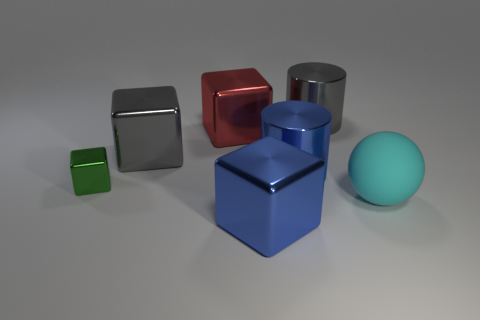Subtract 1 blocks. How many blocks are left? 3 Add 2 large yellow rubber objects. How many objects exist? 9 Subtract 1 blue cubes. How many objects are left? 6 Subtract all balls. How many objects are left? 6 Subtract all big blue cylinders. Subtract all gray objects. How many objects are left? 4 Add 1 tiny objects. How many tiny objects are left? 2 Add 1 blue metal cubes. How many blue metal cubes exist? 2 